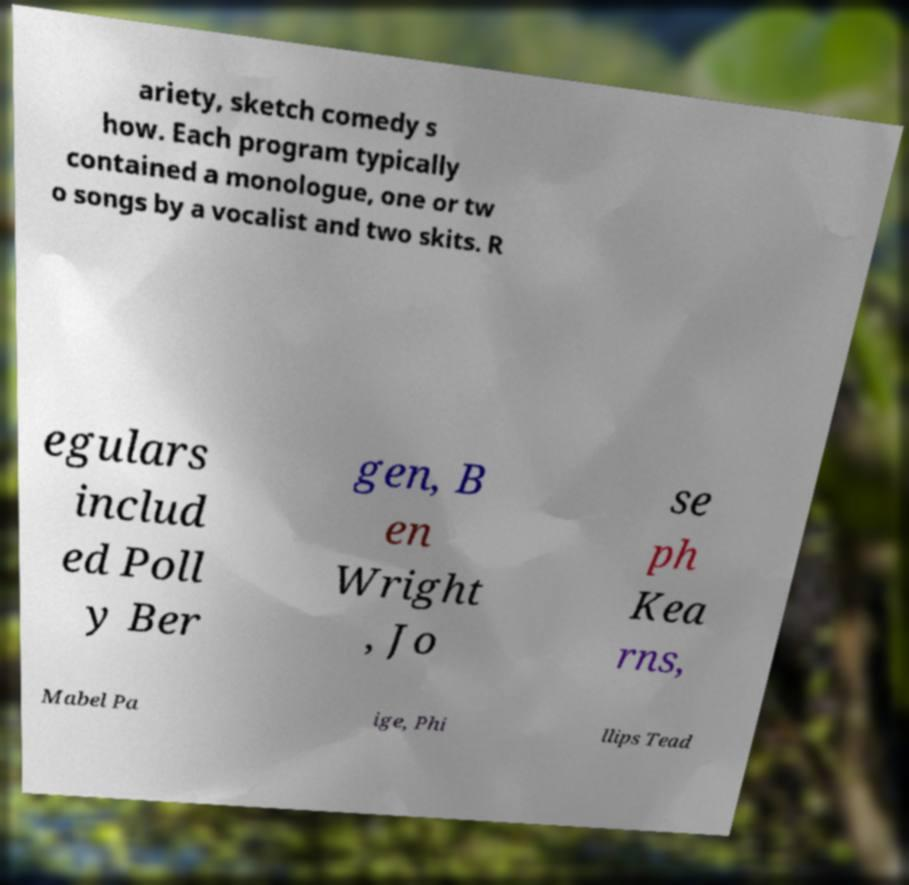There's text embedded in this image that I need extracted. Can you transcribe it verbatim? ariety, sketch comedy s how. Each program typically contained a monologue, one or tw o songs by a vocalist and two skits. R egulars includ ed Poll y Ber gen, B en Wright , Jo se ph Kea rns, Mabel Pa ige, Phi llips Tead 